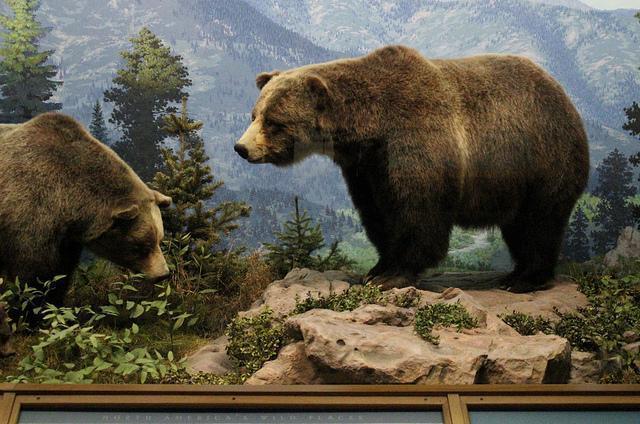How many bears are fully visible?
Give a very brief answer. 1. How many bears are there?
Give a very brief answer. 2. 